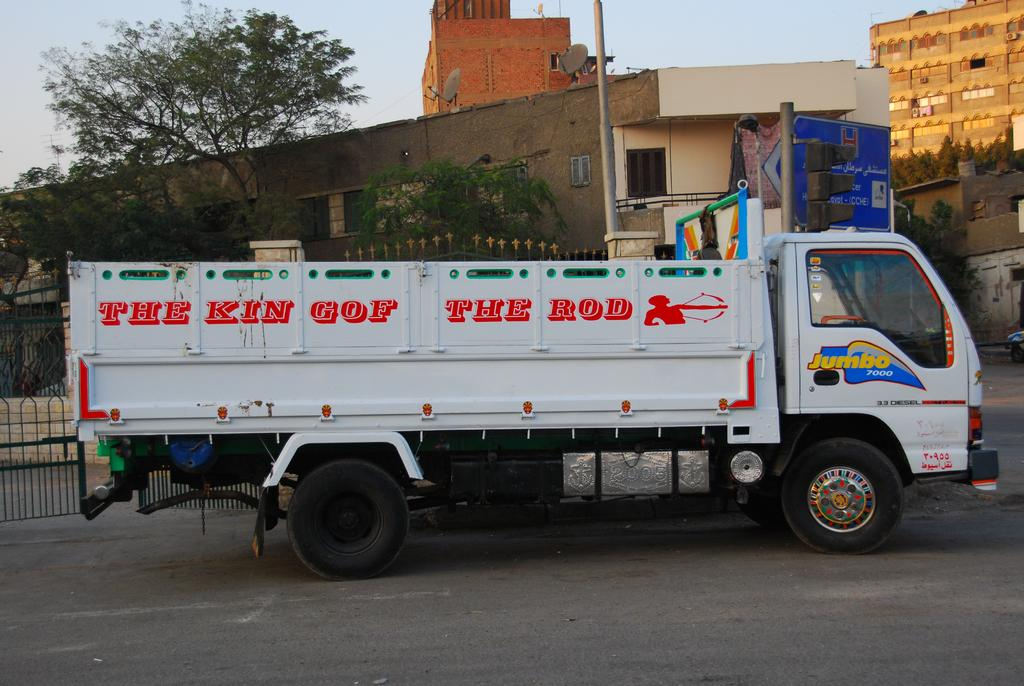<image>
Create a compact narrative representing the image presented. White  Jumbo seven thousand truck with the king of the rod wrote on the side. 